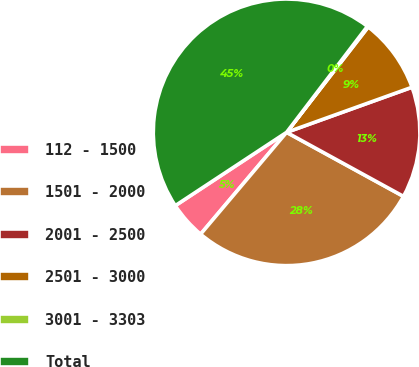<chart> <loc_0><loc_0><loc_500><loc_500><pie_chart><fcel>112 - 1500<fcel>1501 - 2000<fcel>2001 - 2500<fcel>2501 - 3000<fcel>3001 - 3303<fcel>Total<nl><fcel>4.57%<fcel>28.18%<fcel>13.47%<fcel>9.02%<fcel>0.12%<fcel>44.63%<nl></chart> 